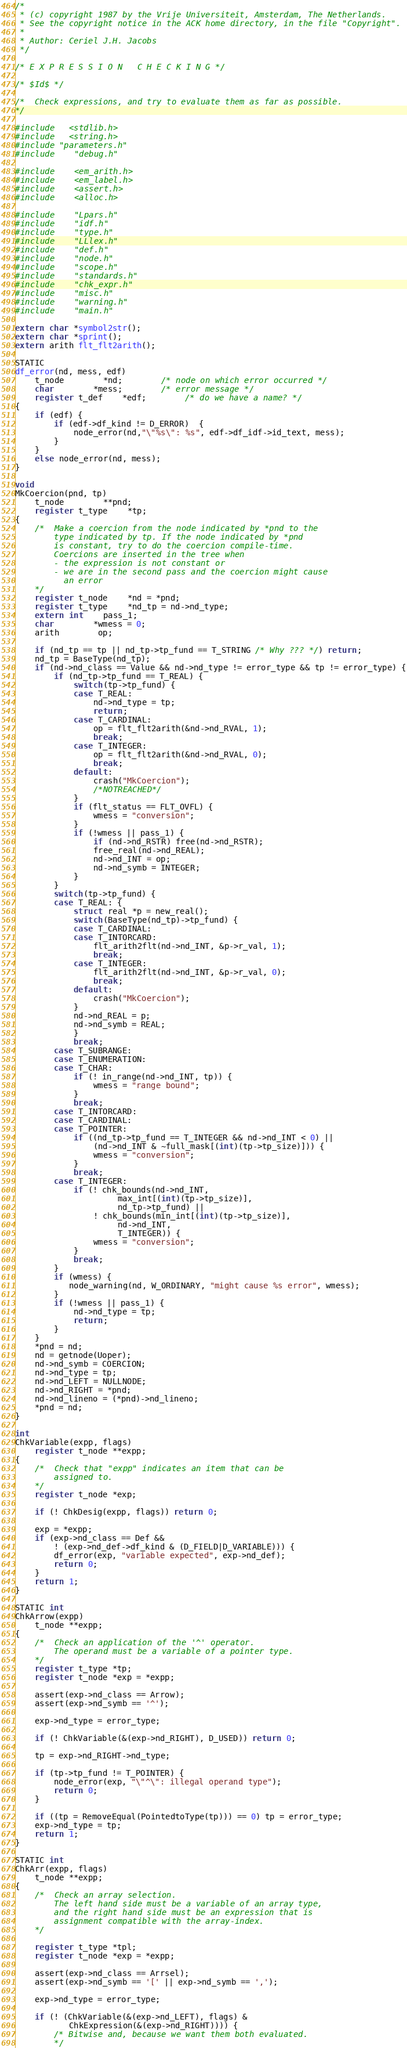Convert code to text. <code><loc_0><loc_0><loc_500><loc_500><_C_>/*
 * (c) copyright 1987 by the Vrije Universiteit, Amsterdam, The Netherlands.
 * See the copyright notice in the ACK home directory, in the file "Copyright".
 *
 * Author: Ceriel J.H. Jacobs
 */

/* E X P R E S S I O N   C H E C K I N G */

/* $Id$ */

/*	Check expressions, and try to evaluate them as far as possible.
*/

#include   <stdlib.h>
#include   <string.h>
#include "parameters.h"
#include	"debug.h"

#include	<em_arith.h>
#include	<em_label.h>
#include	<assert.h>
#include	<alloc.h>

#include	"Lpars.h"
#include	"idf.h"
#include	"type.h"
#include	"LLlex.h"
#include	"def.h"
#include	"node.h"
#include	"scope.h"
#include	"standards.h"
#include	"chk_expr.h"
#include	"misc.h"
#include	"warning.h"
#include	"main.h"

extern char *symbol2str();
extern char *sprint();
extern arith flt_flt2arith();

STATIC
df_error(nd, mess, edf)
	t_node		*nd;		/* node on which error occurred */
	char		*mess;		/* error message */
	register t_def	*edf;		/* do we have a name? */
{
	if (edf) {
		if (edf->df_kind != D_ERROR)  {
			node_error(nd,"\"%s\": %s", edf->df_idf->id_text, mess);
		}
	}
	else node_error(nd, mess);
}

void
MkCoercion(pnd, tp)
	t_node		**pnd;
	register t_type	*tp;
{
	/*	Make a coercion from the node indicated by *pnd to the
		type indicated by tp. If the node indicated by *pnd
		is constant, try to do the coercion compile-time.
		Coercions are inserted in the tree when
		- the expression is not constant or
		- we are in the second pass and the coercion might cause
		  an error
	*/
	register t_node	*nd = *pnd;
	register t_type	*nd_tp = nd->nd_type;
	extern int	pass_1;
	char		*wmess = 0;
	arith		op;

	if (nd_tp == tp || nd_tp->tp_fund == T_STRING /* Why ??? */) return;
	nd_tp = BaseType(nd_tp);
	if (nd->nd_class == Value && nd->nd_type != error_type && tp != error_type) {
		if (nd_tp->tp_fund == T_REAL) {
			switch(tp->tp_fund) {
			case T_REAL:
				nd->nd_type = tp;
				return;
			case T_CARDINAL:
				op = flt_flt2arith(&nd->nd_RVAL, 1);
				break;
			case T_INTEGER:
				op = flt_flt2arith(&nd->nd_RVAL, 0);
				break;
			default:
				crash("MkCoercion");
				/*NOTREACHED*/
			}
			if (flt_status == FLT_OVFL) {
				wmess = "conversion";
			}
			if (!wmess || pass_1) {
				if (nd->nd_RSTR) free(nd->nd_RSTR);
				free_real(nd->nd_REAL);
				nd->nd_INT = op;
				nd->nd_symb = INTEGER;
			}
		}
		switch(tp->tp_fund) {
		case T_REAL: {
			struct real *p = new_real();
			switch(BaseType(nd_tp)->tp_fund) {
			case T_CARDINAL:
			case T_INTORCARD:
				flt_arith2flt(nd->nd_INT, &p->r_val, 1);
				break;
			case T_INTEGER:
				flt_arith2flt(nd->nd_INT, &p->r_val, 0);
				break;
			default:
				crash("MkCoercion");
			}
			nd->nd_REAL = p;
			nd->nd_symb = REAL;
			}
			break;
		case T_SUBRANGE:
		case T_ENUMERATION:
		case T_CHAR:
			if (! in_range(nd->nd_INT, tp)) {
				wmess = "range bound";
			}
			break;
		case T_INTORCARD:
		case T_CARDINAL:
		case T_POINTER:
			if ((nd_tp->tp_fund == T_INTEGER && nd->nd_INT < 0) ||
			    (nd->nd_INT & ~full_mask[(int)(tp->tp_size)])) {
				wmess = "conversion";
			}
			break;
		case T_INTEGER:
			if (! chk_bounds(nd->nd_INT,
					 max_int[(int)(tp->tp_size)],
					 nd_tp->tp_fund) ||
			    ! chk_bounds(min_int[(int)(tp->tp_size)],
					 nd->nd_INT,
					 T_INTEGER)) {
				wmess = "conversion";
			}
			break;
		}
		if (wmess) {
		   node_warning(nd, W_ORDINARY, "might cause %s error", wmess);
		}
		if (!wmess || pass_1) {
			nd->nd_type = tp;
			return;
		}
	}
	*pnd = nd;
	nd = getnode(Uoper);
	nd->nd_symb = COERCION;
	nd->nd_type = tp;
	nd->nd_LEFT = NULLNODE;
	nd->nd_RIGHT = *pnd;
	nd->nd_lineno = (*pnd)->nd_lineno;
	*pnd = nd;
}

int
ChkVariable(expp, flags)
	register t_node **expp;
{
	/*	Check that "expp" indicates an item that can be
		assigned to.
	*/
	register t_node *exp;

	if (! ChkDesig(expp, flags)) return 0;

	exp = *expp;
	if (exp->nd_class == Def &&
	    ! (exp->nd_def->df_kind & (D_FIELD|D_VARIABLE))) {
		df_error(exp, "variable expected", exp->nd_def);
		return 0;
	}
	return 1;
}

STATIC int
ChkArrow(expp)
	t_node **expp;
{
	/*	Check an application of the '^' operator.
		The operand must be a variable of a pointer type.
	*/
	register t_type *tp;
	register t_node *exp = *expp;

	assert(exp->nd_class == Arrow);
	assert(exp->nd_symb == '^');

	exp->nd_type = error_type;

	if (! ChkVariable(&(exp->nd_RIGHT), D_USED)) return 0;

	tp = exp->nd_RIGHT->nd_type;

	if (tp->tp_fund != T_POINTER) {
		node_error(exp, "\"^\": illegal operand type");
		return 0;
	}

	if ((tp = RemoveEqual(PointedtoType(tp))) == 0) tp = error_type;
	exp->nd_type = tp;
	return 1;
}

STATIC int
ChkArr(expp, flags)
	t_node **expp;
{
	/*	Check an array selection.
		The left hand side must be a variable of an array type,
		and the right hand side must be an expression that is
		assignment compatible with the array-index.
	*/

	register t_type *tpl;
	register t_node *exp = *expp;

	assert(exp->nd_class == Arrsel);
	assert(exp->nd_symb == '[' || exp->nd_symb == ',');

	exp->nd_type = error_type;

	if (! (ChkVariable(&(exp->nd_LEFT), flags) &
	       ChkExpression(&(exp->nd_RIGHT)))) {
		/* Bitwise and, because we want them both evaluated.
		*/</code> 